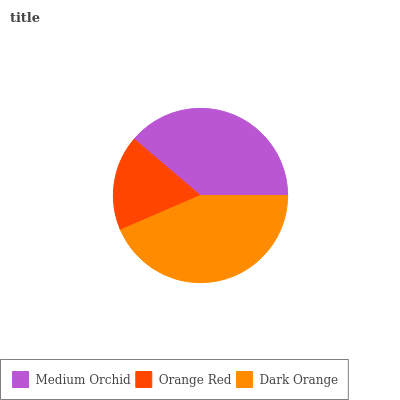Is Orange Red the minimum?
Answer yes or no. Yes. Is Dark Orange the maximum?
Answer yes or no. Yes. Is Dark Orange the minimum?
Answer yes or no. No. Is Orange Red the maximum?
Answer yes or no. No. Is Dark Orange greater than Orange Red?
Answer yes or no. Yes. Is Orange Red less than Dark Orange?
Answer yes or no. Yes. Is Orange Red greater than Dark Orange?
Answer yes or no. No. Is Dark Orange less than Orange Red?
Answer yes or no. No. Is Medium Orchid the high median?
Answer yes or no. Yes. Is Medium Orchid the low median?
Answer yes or no. Yes. Is Orange Red the high median?
Answer yes or no. No. Is Dark Orange the low median?
Answer yes or no. No. 